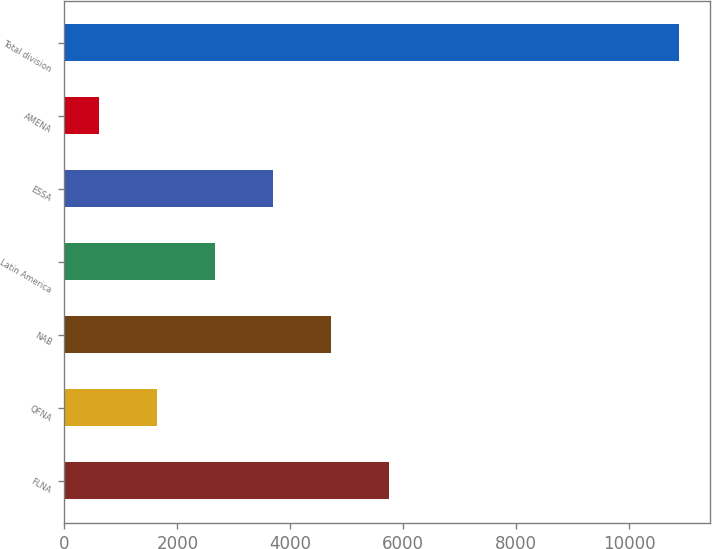Convert chart. <chart><loc_0><loc_0><loc_500><loc_500><bar_chart><fcel>FLNA<fcel>QFNA<fcel>NAB<fcel>Latin America<fcel>ESSA<fcel>AMENA<fcel>Total division<nl><fcel>5752<fcel>1645.6<fcel>4725.4<fcel>2672.2<fcel>3698.8<fcel>619<fcel>10885<nl></chart> 